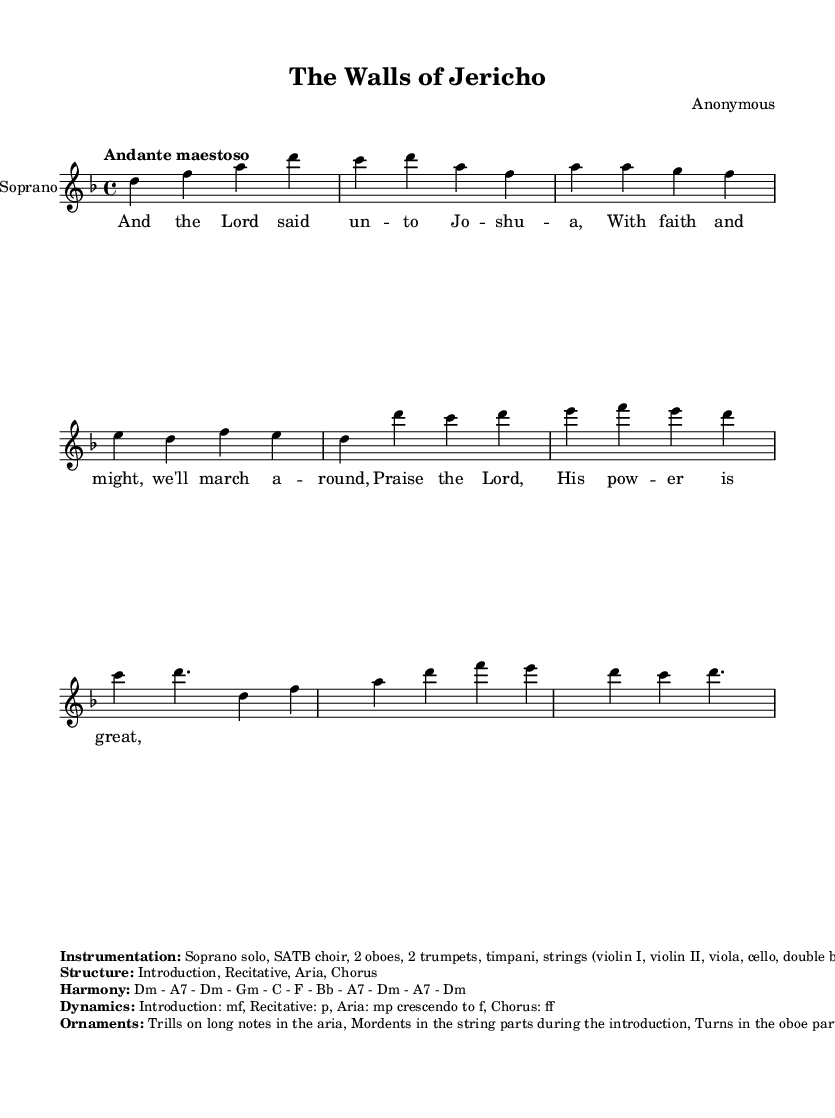What is the key signature of this music? The key signature is D minor, which has one flat (B flat). This is determined from the key indicated at the start of the music, located at the beginning of the staff.
Answer: D minor What is the time signature of this piece? The time signature is 4/4, as indicated in the piece, found near the beginning right after the key signature. It shows that there are four beats in each measure.
Answer: 4/4 What is the tempo marking given for the piece? The tempo marking is "Andante maestoso," which indicates a moderately slow and stately pace for the performance. This is noted at the beginning of the score.
Answer: Andante maestoso How many sections are described in the structure? The structure of the piece includes four sections: Introduction, Recitative, Aria, and Chorus. This is mentioned in the markup describing the structure of the composition.
Answer: Four What instruments are included in the instrumentation? The instrumentation includes Soprano solo, SATB choir, 2 oboes, 2 trumpets, timpani, strings, and harpsichord. This information is outlined in the markup section labeled "Instrumentation."
Answer: Soprano solo, SATB choir, 2 oboes, 2 trumpets, timpani, strings, harpsichord What dynamics are specified for the Chorus section? The dynamics specified for the Chorus section are fortissimo (ff), indicating it should be played very loudly. This is detailed in the markup section labeled "Dynamics."
Answer: ff What harmonic progression is used in the piece? The harmonic progression listed in the markup is D minor, A7, G minor, C, F, B flat, A7, D minor. This sequence is noted in the section labeled "Harmony" and indicates the chords used throughout the music.
Answer: Dm - A7 - Gm - C - F - Bb - A7 - Dm 